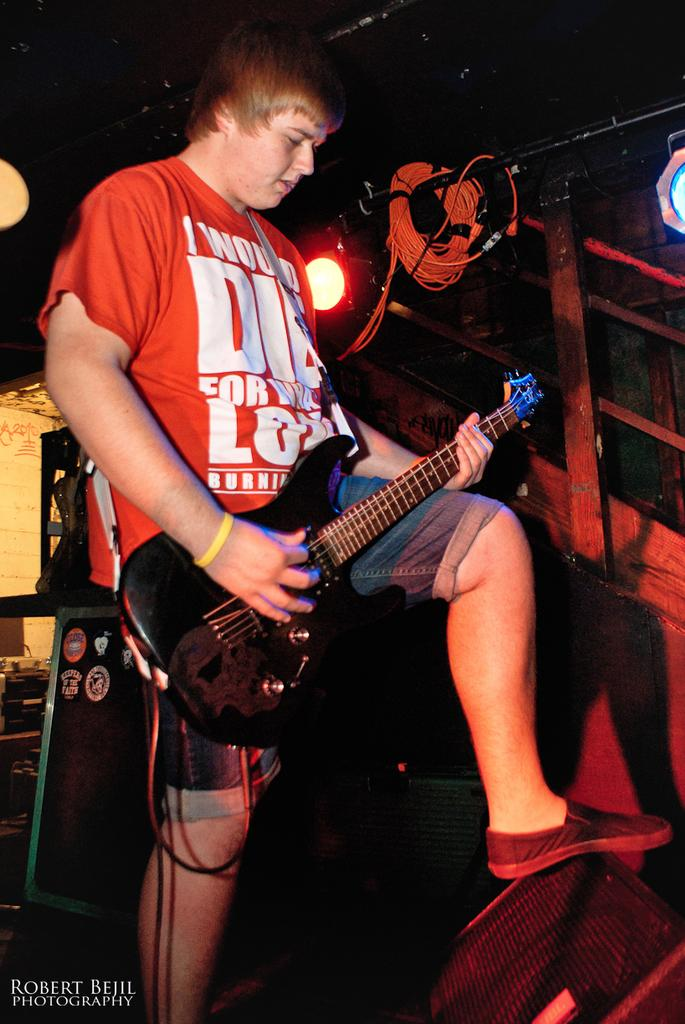Who is present in the image? There is a man in the image. What is the man doing in the image? The man is standing on the floor and holding a guitar in his hands. What is in front of the man? There is a stand in front of the man. What can be seen in the background of the image? There are lights visible in the image. Reasoning: Let'ing: Let's think step by step in order to produce the conversation. We start by identifying the main subject in the image, which is the man. Then, we describe what the man is doing and what is in front of him. Finally, we mention the background elements that are visible in the image, such as the lights. Each question is designed to elicit a specific detail about the image that is known from the provided facts. Absurd Question/Answer: What type of spade is the man using to dig in the image? There is no spade present in the image; the man is holding a guitar. What is the relation between the man and the person standing next to him in the image? There is no other person present in the image; only the man and his guitar are visible. 